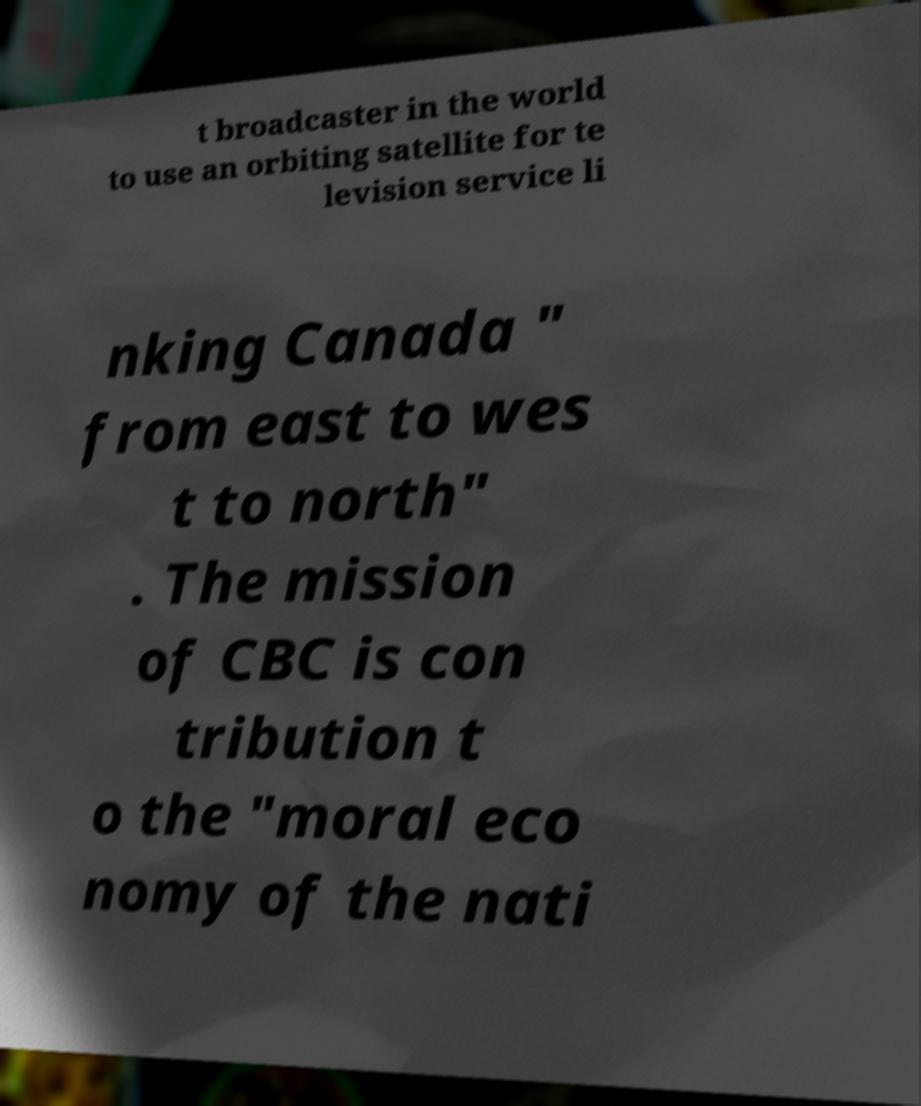Could you extract and type out the text from this image? t broadcaster in the world to use an orbiting satellite for te levision service li nking Canada " from east to wes t to north" . The mission of CBC is con tribution t o the "moral eco nomy of the nati 